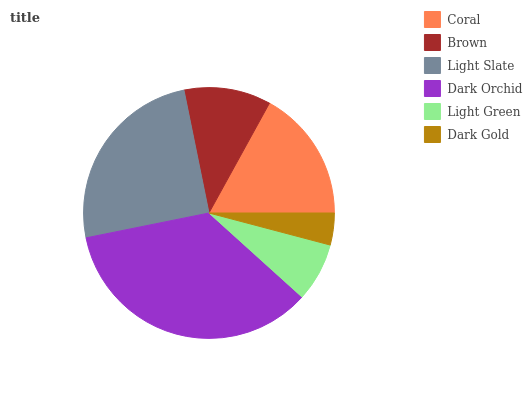Is Dark Gold the minimum?
Answer yes or no. Yes. Is Dark Orchid the maximum?
Answer yes or no. Yes. Is Brown the minimum?
Answer yes or no. No. Is Brown the maximum?
Answer yes or no. No. Is Coral greater than Brown?
Answer yes or no. Yes. Is Brown less than Coral?
Answer yes or no. Yes. Is Brown greater than Coral?
Answer yes or no. No. Is Coral less than Brown?
Answer yes or no. No. Is Coral the high median?
Answer yes or no. Yes. Is Brown the low median?
Answer yes or no. Yes. Is Dark Gold the high median?
Answer yes or no. No. Is Coral the low median?
Answer yes or no. No. 